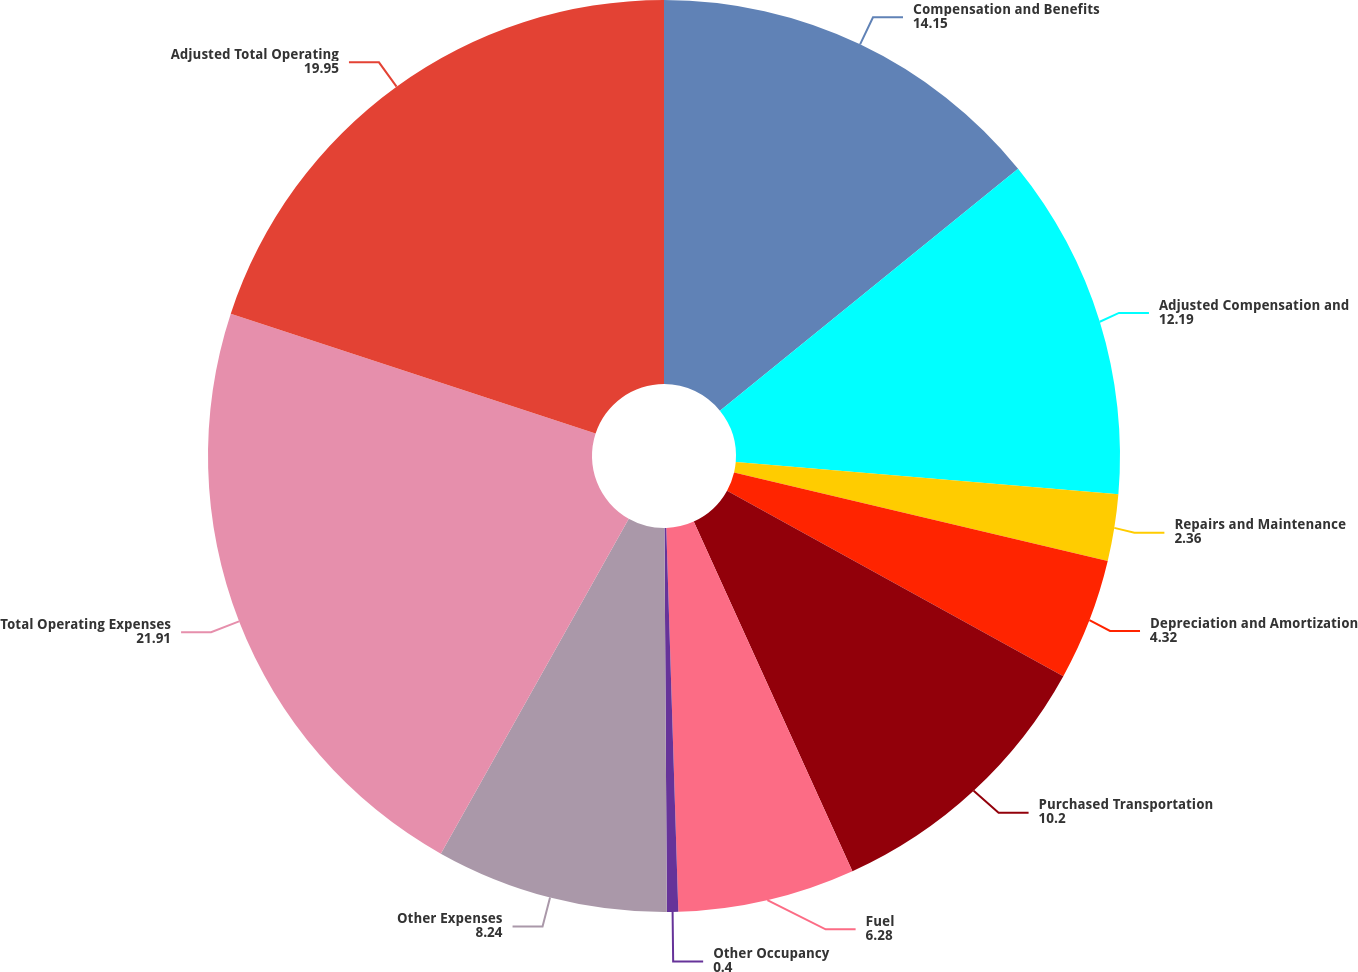Convert chart to OTSL. <chart><loc_0><loc_0><loc_500><loc_500><pie_chart><fcel>Compensation and Benefits<fcel>Adjusted Compensation and<fcel>Repairs and Maintenance<fcel>Depreciation and Amortization<fcel>Purchased Transportation<fcel>Fuel<fcel>Other Occupancy<fcel>Other Expenses<fcel>Total Operating Expenses<fcel>Adjusted Total Operating<nl><fcel>14.15%<fcel>12.19%<fcel>2.36%<fcel>4.32%<fcel>10.2%<fcel>6.28%<fcel>0.4%<fcel>8.24%<fcel>21.91%<fcel>19.95%<nl></chart> 